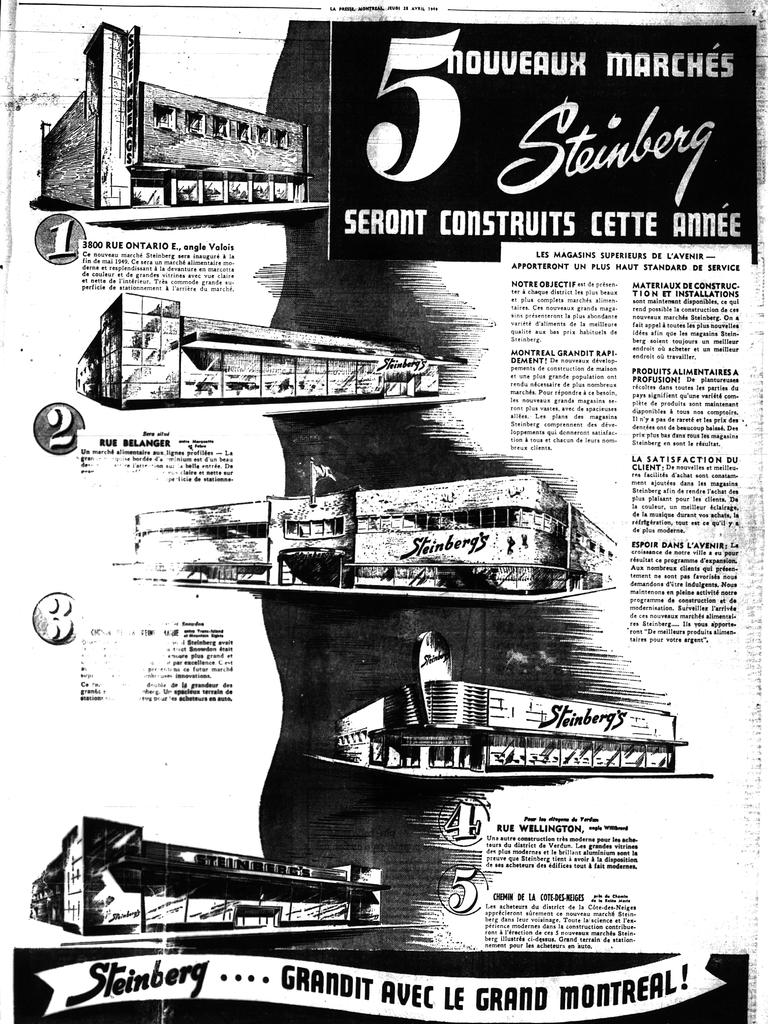<image>
Give a short and clear explanation of the subsequent image. Page from a black and white publication with the title 5nouveaux marches Steinberg at the top. 